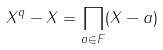<formula> <loc_0><loc_0><loc_500><loc_500>X ^ { q } - X = \prod _ { a \in F } ( X - a )</formula> 